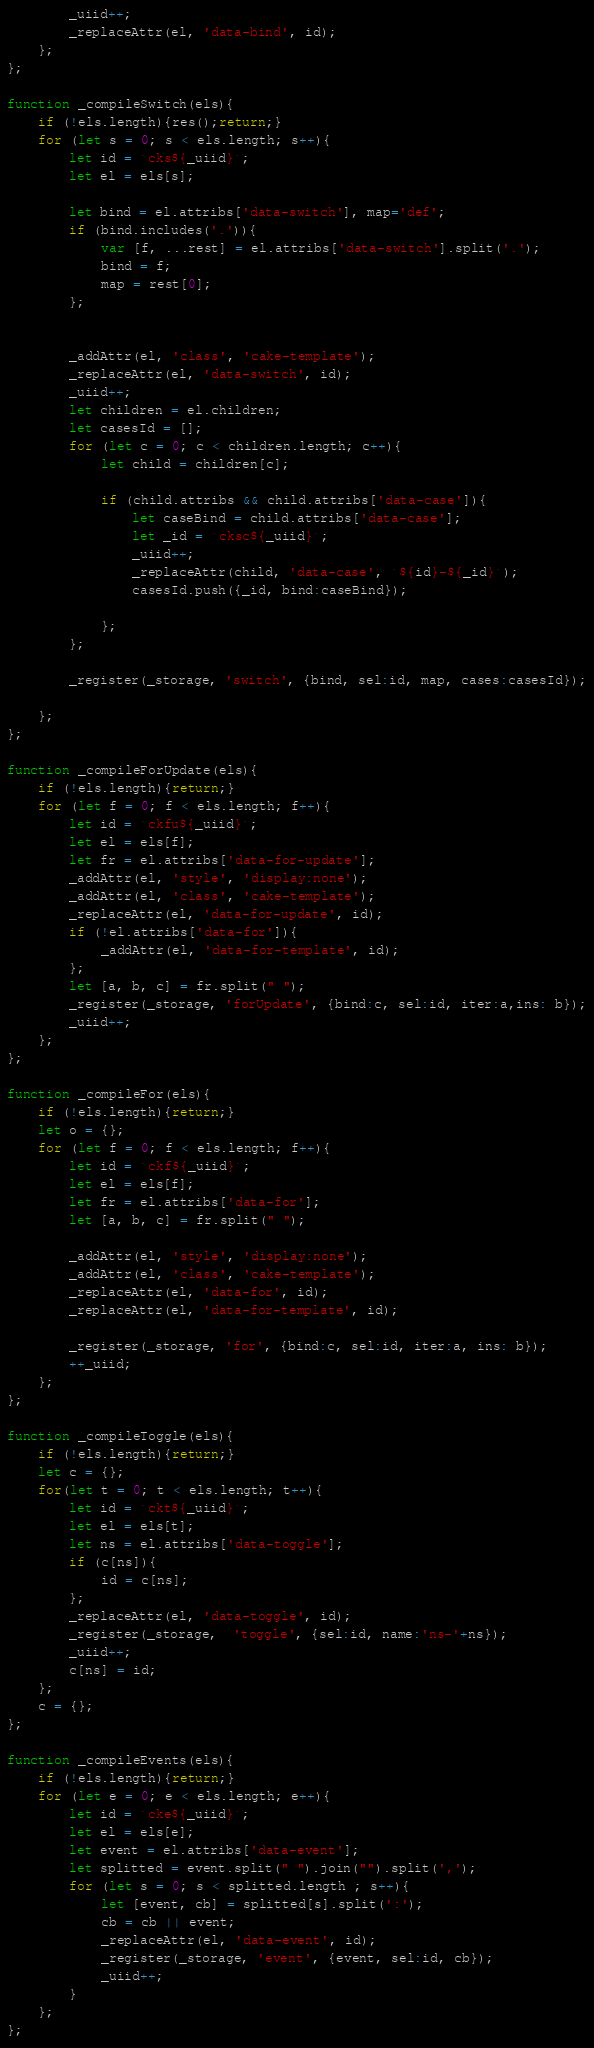<code> <loc_0><loc_0><loc_500><loc_500><_JavaScript_>        _uiid++;
        _replaceAttr(el, 'data-bind', id);
    };
};

function _compileSwitch(els){
    if (!els.length){res();return;}
    for (let s = 0; s < els.length; s++){
        let id = `cks${_uiid}`;
        let el = els[s];

        let bind = el.attribs['data-switch'], map='def';
        if (bind.includes('.')){
            var [f, ...rest] = el.attribs['data-switch'].split('.');
            bind = f;
            map = rest[0];
        };


        _addAttr(el, 'class', 'cake-template');
        _replaceAttr(el, 'data-switch', id);
        _uiid++;
        let children = el.children;
        let casesId = [];
        for (let c = 0; c < children.length; c++){
            let child = children[c];

            if (child.attribs && child.attribs['data-case']){
                let caseBind = child.attribs['data-case'];
                let _id = `cksc${_uiid}`;
                _uiid++;
                _replaceAttr(child, 'data-case', `${id}-${_id}`);
                casesId.push({_id, bind:caseBind});

            };
        };

        _register(_storage, 'switch', {bind, sel:id, map, cases:casesId});
       
    };
};

function _compileForUpdate(els){
    if (!els.length){return;}
    for (let f = 0; f < els.length; f++){
        let id = `ckfu${_uiid}`;
        let el = els[f];
        let fr = el.attribs['data-for-update'];
        _addAttr(el, 'style', 'display:none');
        _addAttr(el, 'class', 'cake-template');
        _replaceAttr(el, 'data-for-update', id);
        if (!el.attribs['data-for']){
            _addAttr(el, 'data-for-template', id);
        };
        let [a, b, c] = fr.split(" ");
        _register(_storage, 'forUpdate', {bind:c, sel:id, iter:a,ins: b});
        _uiid++;
    };
};

function _compileFor(els){
    if (!els.length){return;}
    let o = {};
    for (let f = 0; f < els.length; f++){
        let id = `ckf${_uiid}`;
        let el = els[f];
        let fr = el.attribs['data-for'];
        let [a, b, c] = fr.split(" ");

        _addAttr(el, 'style', 'display:none');
        _addAttr(el, 'class', 'cake-template');
        _replaceAttr(el, 'data-for', id);
        _replaceAttr(el, 'data-for-template', id);

        _register(_storage, 'for', {bind:c, sel:id, iter:a, ins: b});
        ++_uiid;
    };
};

function _compileToggle(els){
    if (!els.length){return;}
    let c = {};
    for(let t = 0; t < els.length; t++){
        let id = `ckt${_uiid}`;
        let el = els[t];
        let ns = el.attribs['data-toggle'];
        if (c[ns]){
            id = c[ns];
        };
        _replaceAttr(el, 'data-toggle', id);
        _register(_storage,  'toggle', {sel:id, name:'ns-'+ns});
        _uiid++;
        c[ns] = id;
    };
    c = {};
};

function _compileEvents(els){
    if (!els.length){return;}
    for (let e = 0; e < els.length; e++){
        let id = `cke${_uiid}`;
        let el = els[e];
        let event = el.attribs['data-event'];
        let splitted = event.split(" ").join("").split(',');
        for (let s = 0; s < splitted.length ; s++){
            let [event, cb] = splitted[s].split(':');
            cb = cb || event;
            _replaceAttr(el, 'data-event', id);
            _register(_storage, 'event', {event, sel:id, cb});
            _uiid++;
        }
    };
};</code> 